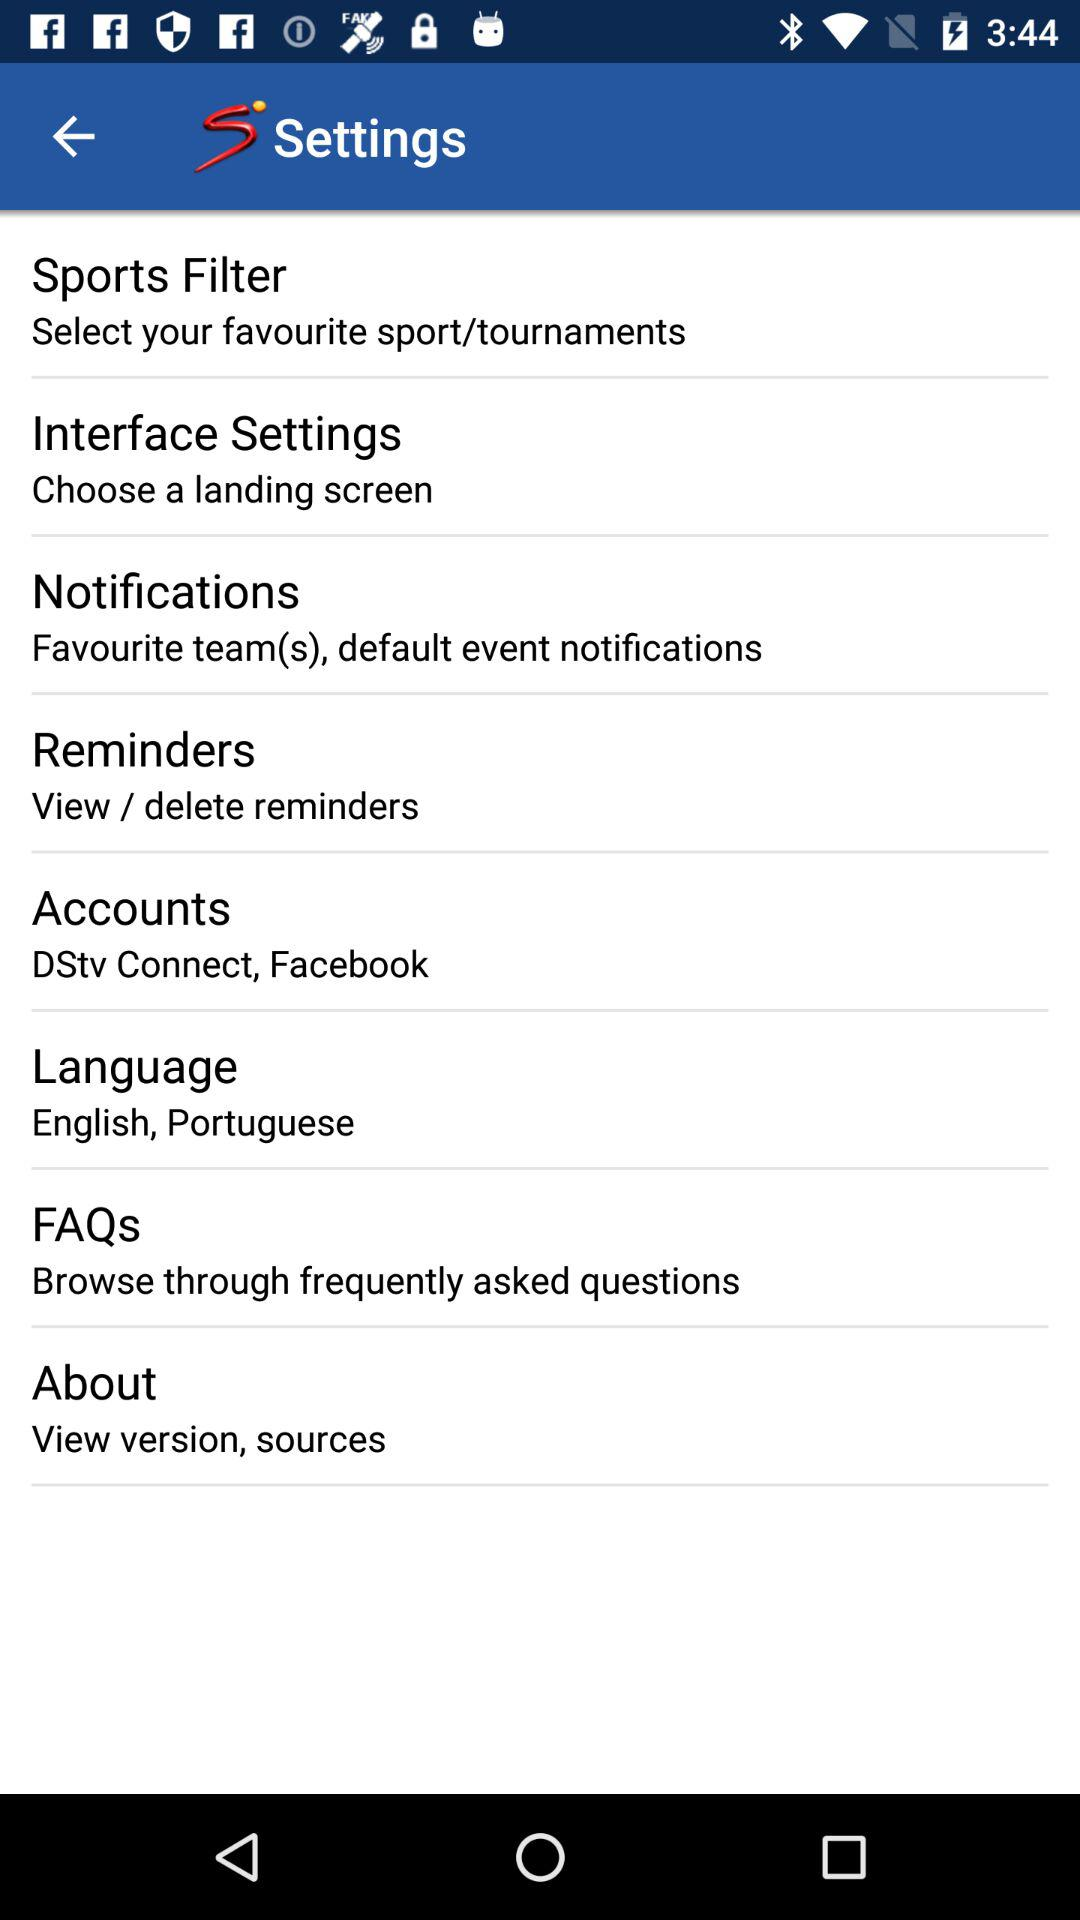What language is shown in the settings? The languages are English and Portuguese. 